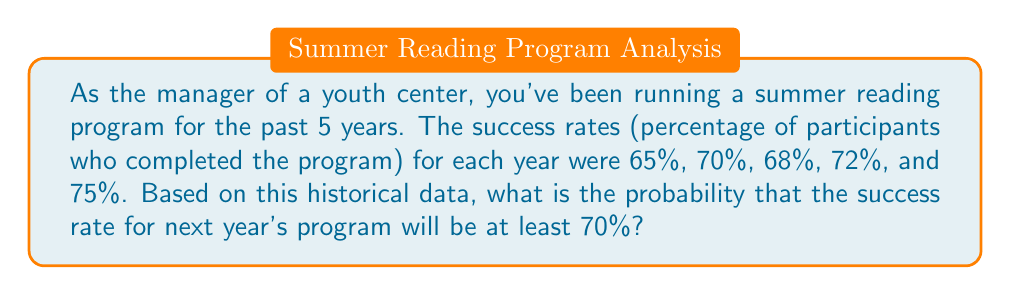Could you help me with this problem? To solve this problem, we'll use the following steps:

1) First, we need to determine how many times the success rate was at least 70% in the past 5 years.

   The success rates were: 65%, 70%, 68%, 72%, and 75%
   Of these, 3 are at least 70% (70%, 72%, and 75%)

2) Now, we can calculate the probability using the formula:

   $$P(\text{success rate} \geq 70\%) = \frac{\text{Number of favorable outcomes}}{\text{Total number of outcomes}}$$

3) Substituting our values:

   $$P(\text{success rate} \geq 70\%) = \frac{3}{5} = 0.6$$

4) To convert to a percentage:

   $$0.6 \times 100\% = 60\%$$

Therefore, based on the historical data, there is a 60% probability that next year's program will have a success rate of at least 70%.
Answer: 60% 